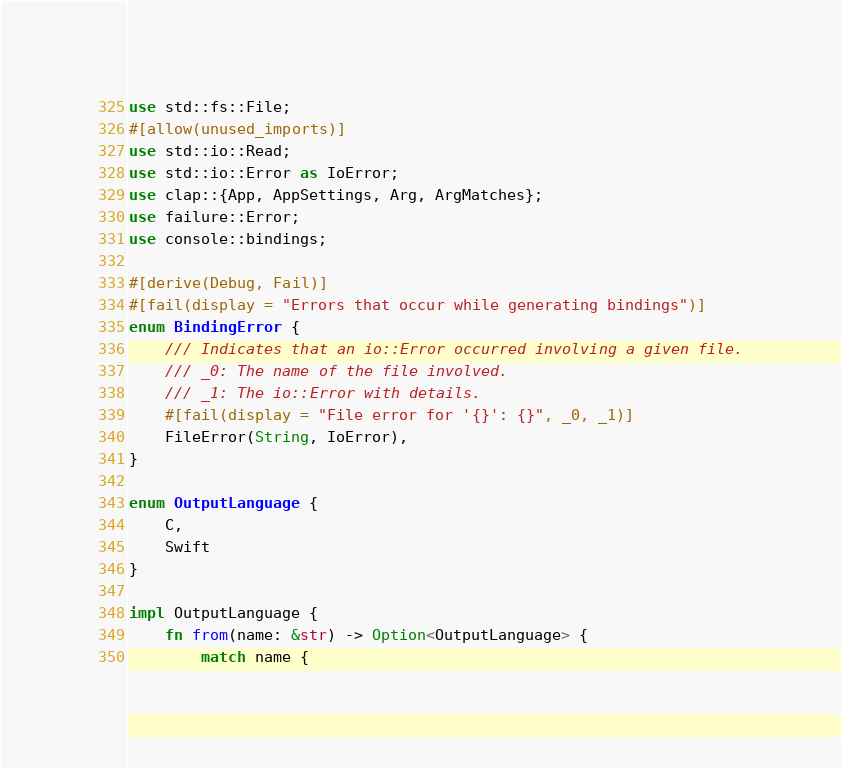<code> <loc_0><loc_0><loc_500><loc_500><_Rust_>use std::fs::File;
#[allow(unused_imports)]
use std::io::Read;
use std::io::Error as IoError;
use clap::{App, AppSettings, Arg, ArgMatches};
use failure::Error;
use console::bindings;

#[derive(Debug, Fail)]
#[fail(display = "Errors that occur while generating bindings")]
enum BindingError {
    /// Indicates that an io::Error occurred involving a given file.
    /// _0: The name of the file involved.
    /// _1: The io::Error with details.
    #[fail(display = "File error for '{}': {}", _0, _1)]
    FileError(String, IoError),
}

enum OutputLanguage {
    C,
    Swift
}

impl OutputLanguage {
    fn from(name: &str) -> Option<OutputLanguage> {
        match name {</code> 